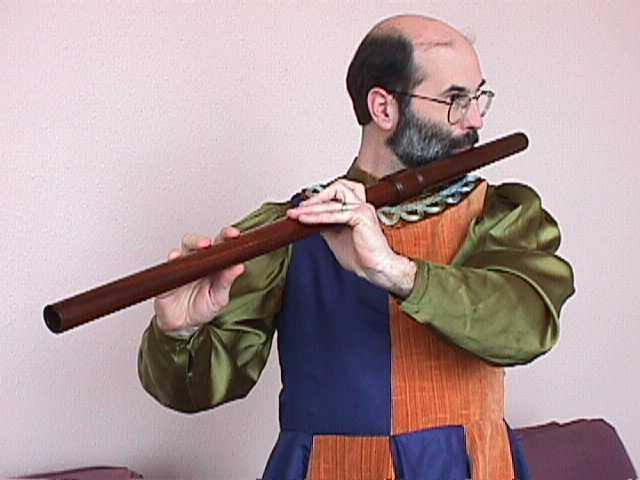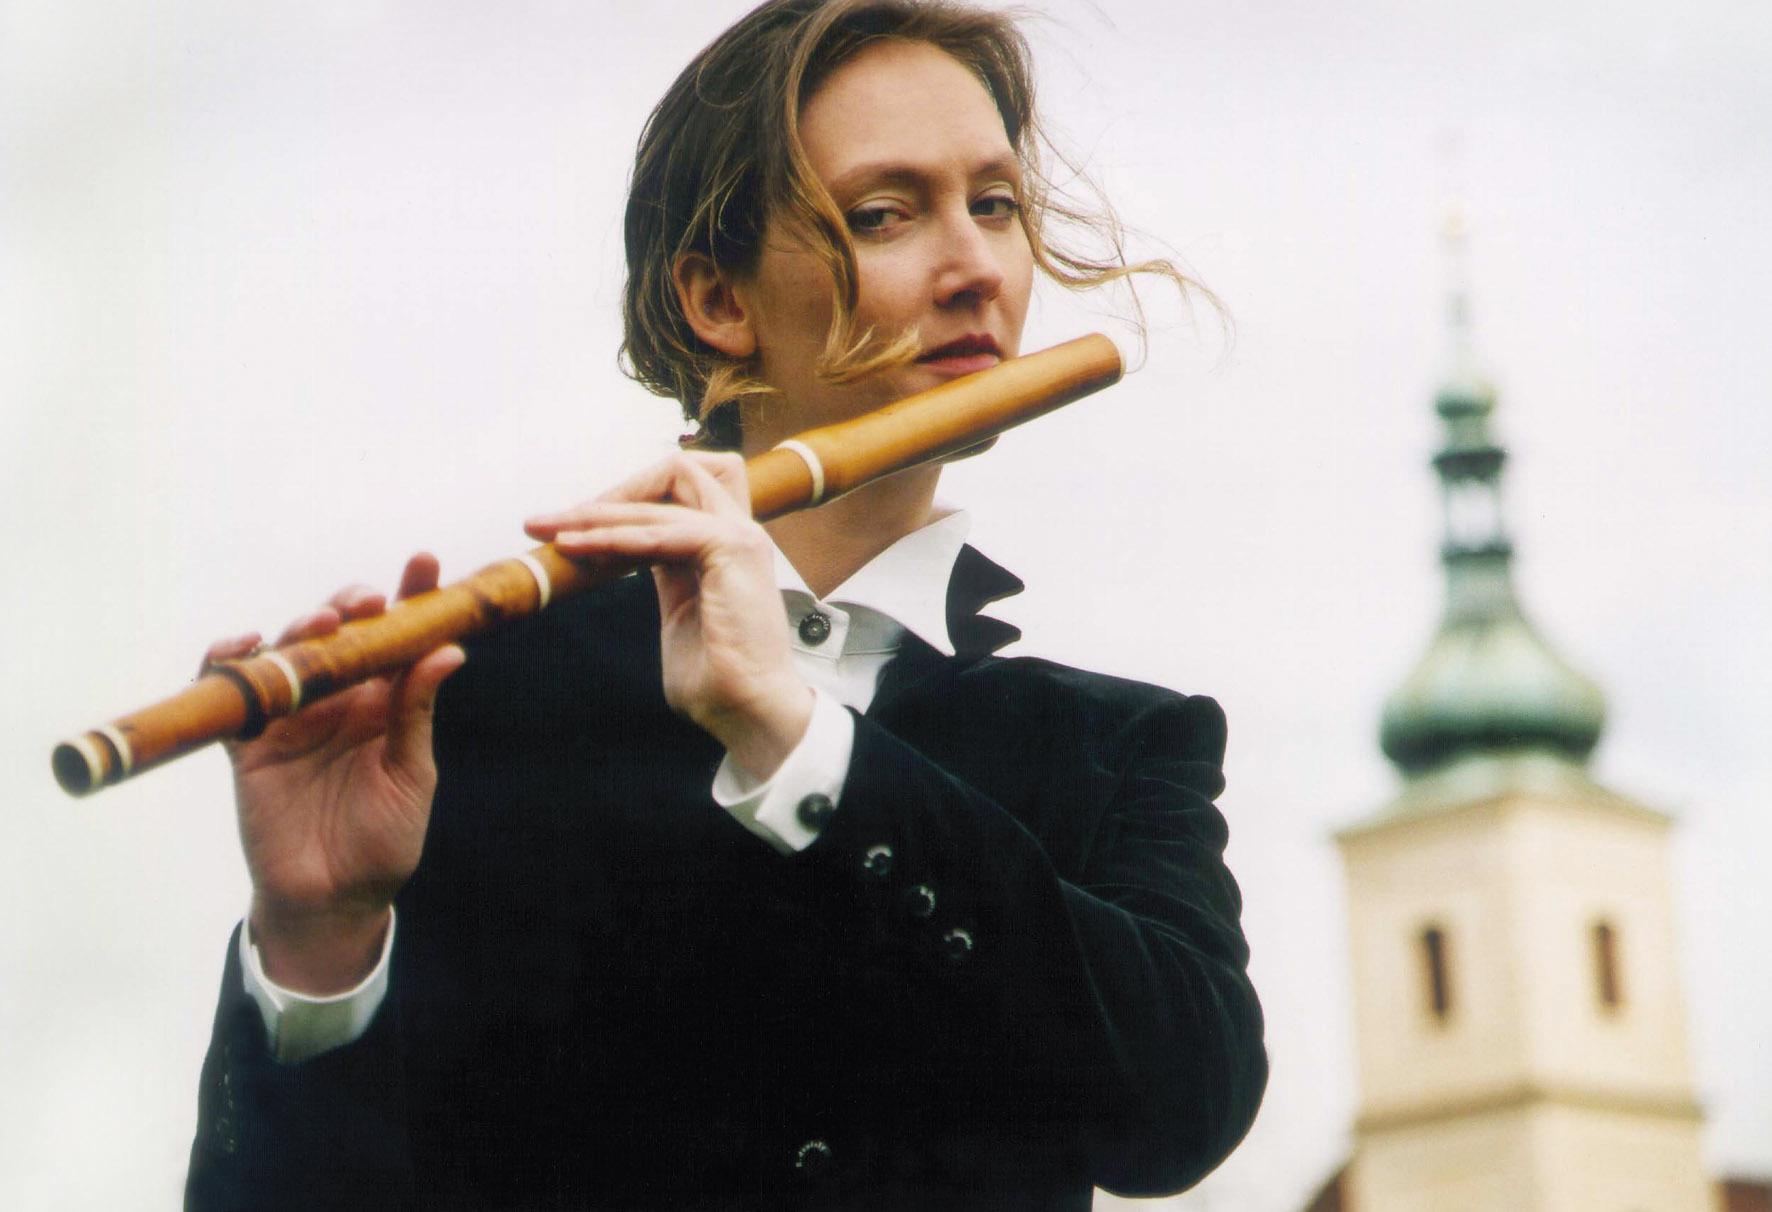The first image is the image on the left, the second image is the image on the right. Given the left and right images, does the statement "At least one of the people is wearing a green shirt." hold true? Answer yes or no. Yes. The first image is the image on the left, the second image is the image on the right. Examine the images to the left and right. Is the description "One image shows one female playing a straight wind instrument, and the other image shows one male in green sleeves playing a wooden wind instrument." accurate? Answer yes or no. Yes. 